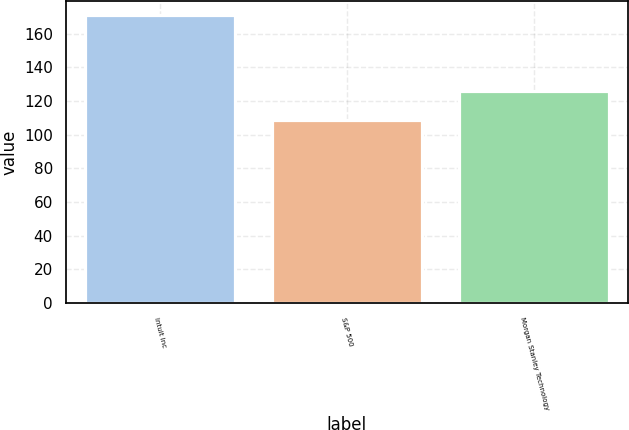Convert chart to OTSL. <chart><loc_0><loc_0><loc_500><loc_500><bar_chart><fcel>Intuit Inc<fcel>S&P 500<fcel>Morgan Stanley Technology<nl><fcel>170.87<fcel>109.02<fcel>125.99<nl></chart> 